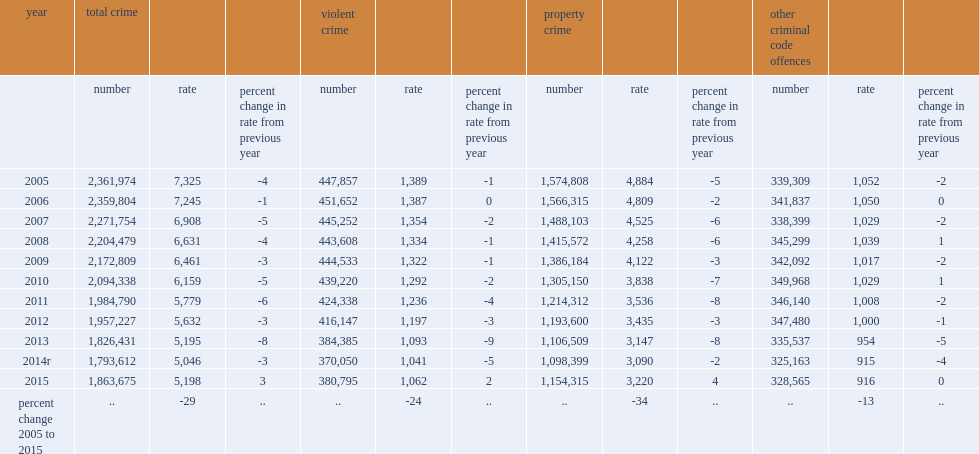The police-reported crime rate was up 3% from the previous year, resulting in what rate of incidents per 100,000 population? 5198.0. In 2015, how many incidents did the violent crime rate in canada per 100,000 population has? 1062.0. In 2015, what is the rate of police-reported property crime in canada increased to? 3220.0. Increases were recorded for every type of property crime. over the same period, what is the rate of other non-violent criminal code offences (excluding traffic)increased in 2015? 916.0. 